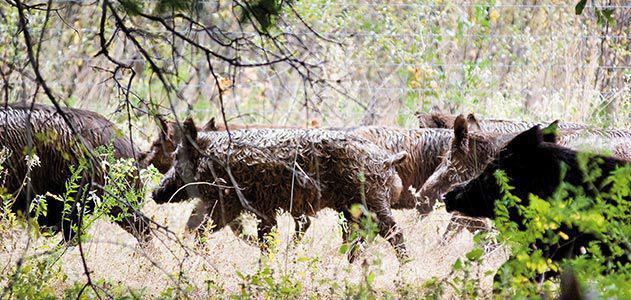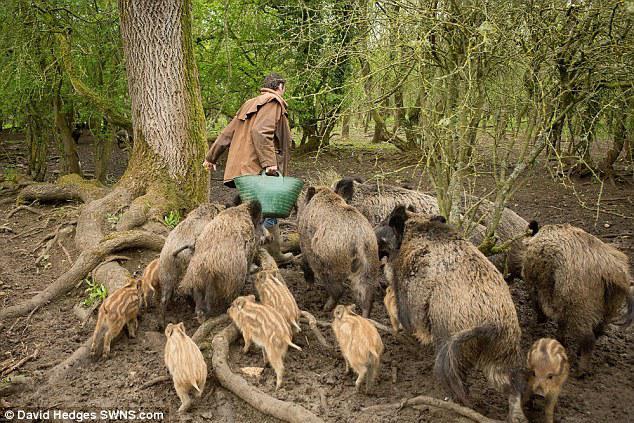The first image is the image on the left, the second image is the image on the right. Assess this claim about the two images: "There are no more than three brown boars in the grass.". Correct or not? Answer yes or no. No. The first image is the image on the left, the second image is the image on the right. Considering the images on both sides, is "There is at most three wild pigs in the right image." valid? Answer yes or no. No. 